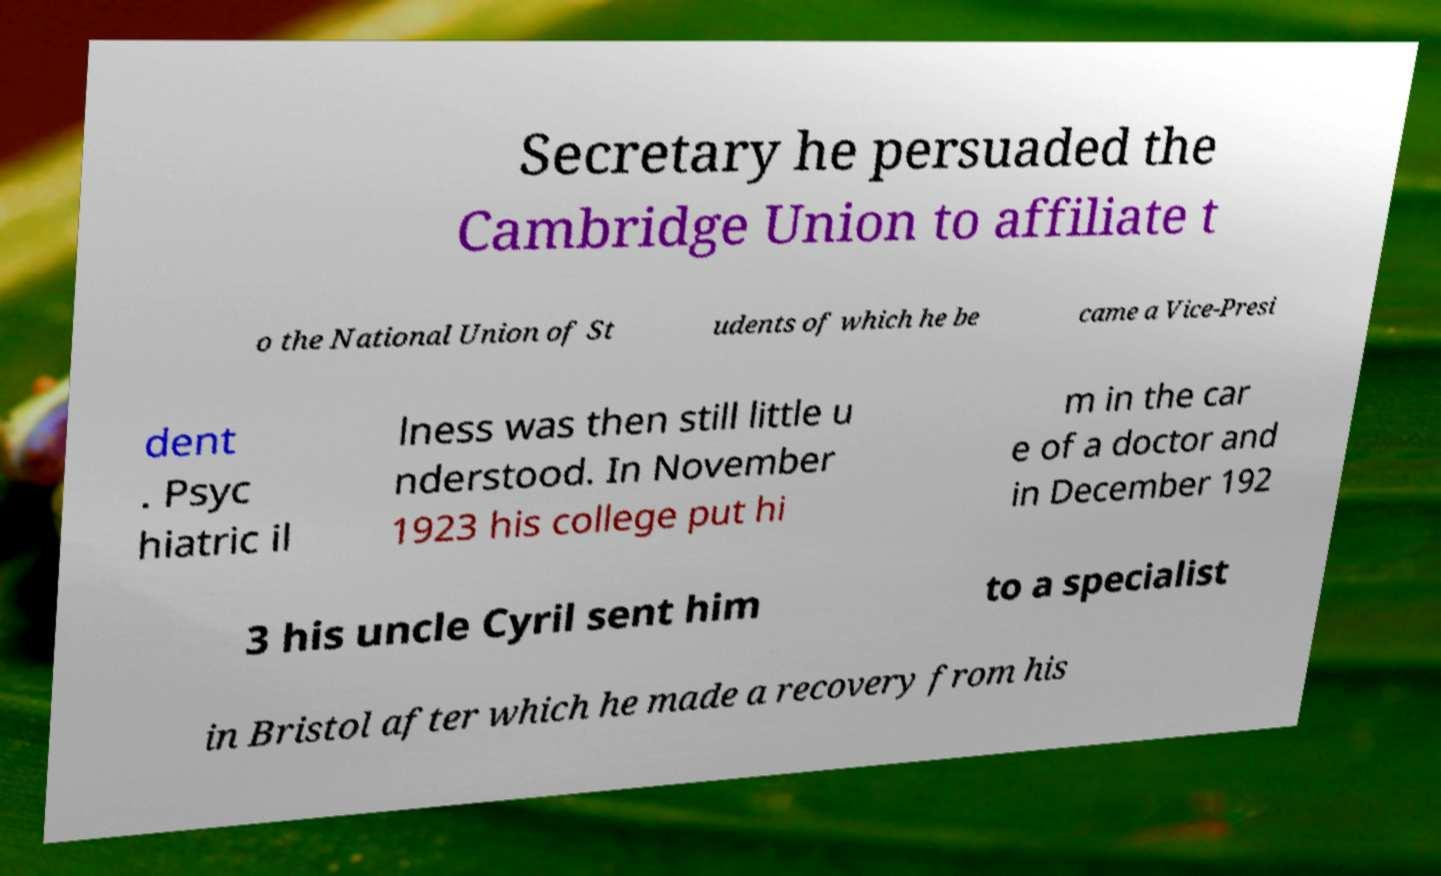Please read and relay the text visible in this image. What does it say? Secretary he persuaded the Cambridge Union to affiliate t o the National Union of St udents of which he be came a Vice-Presi dent . Psyc hiatric il lness was then still little u nderstood. In November 1923 his college put hi m in the car e of a doctor and in December 192 3 his uncle Cyril sent him to a specialist in Bristol after which he made a recovery from his 